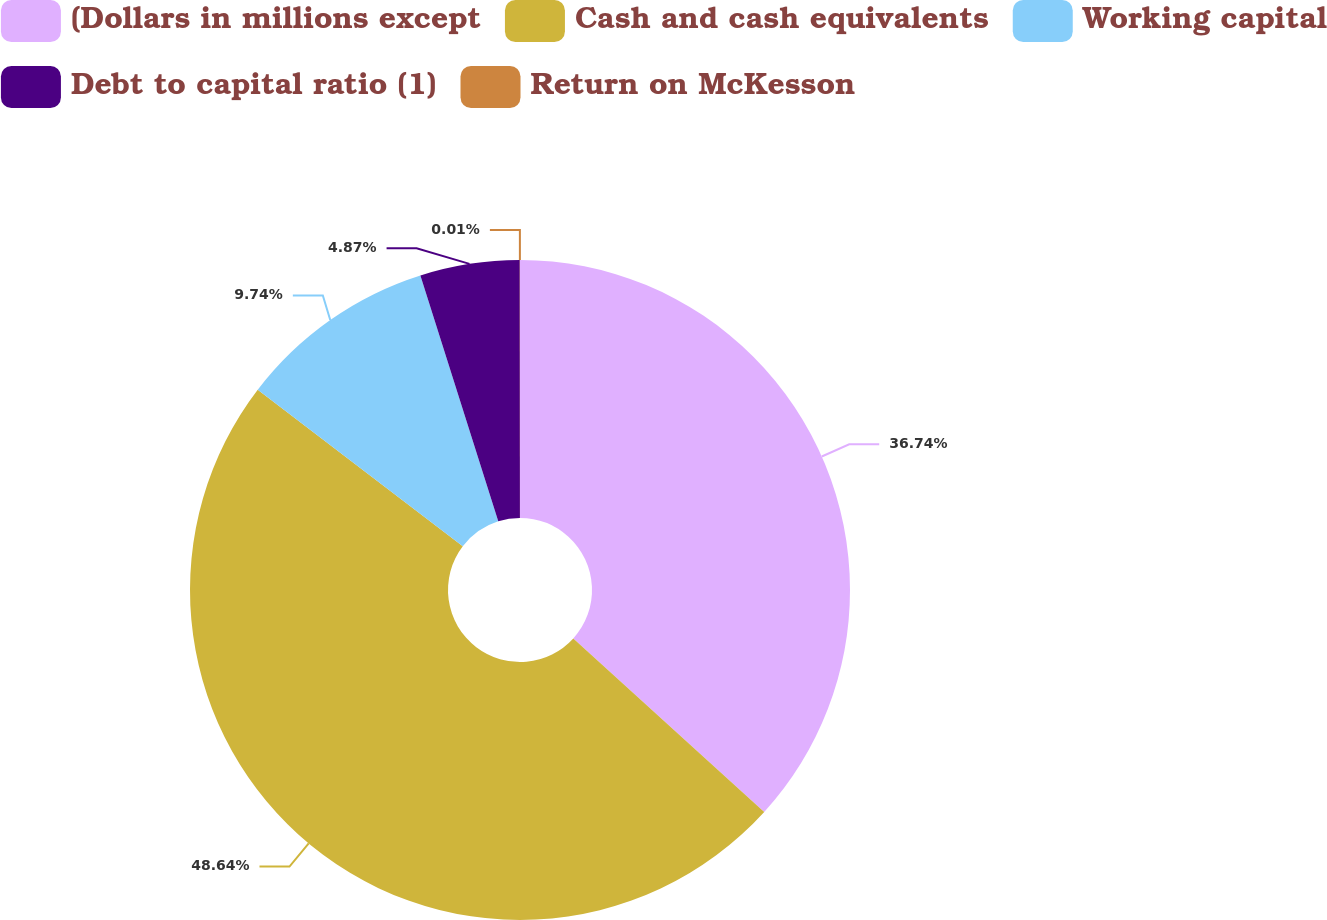Convert chart. <chart><loc_0><loc_0><loc_500><loc_500><pie_chart><fcel>(Dollars in millions except<fcel>Cash and cash equivalents<fcel>Working capital<fcel>Debt to capital ratio (1)<fcel>Return on McKesson<nl><fcel>36.74%<fcel>48.64%<fcel>9.74%<fcel>4.87%<fcel>0.01%<nl></chart> 